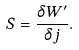<formula> <loc_0><loc_0><loc_500><loc_500>S = \frac { \delta W ^ { \prime } } { \delta j } .</formula> 